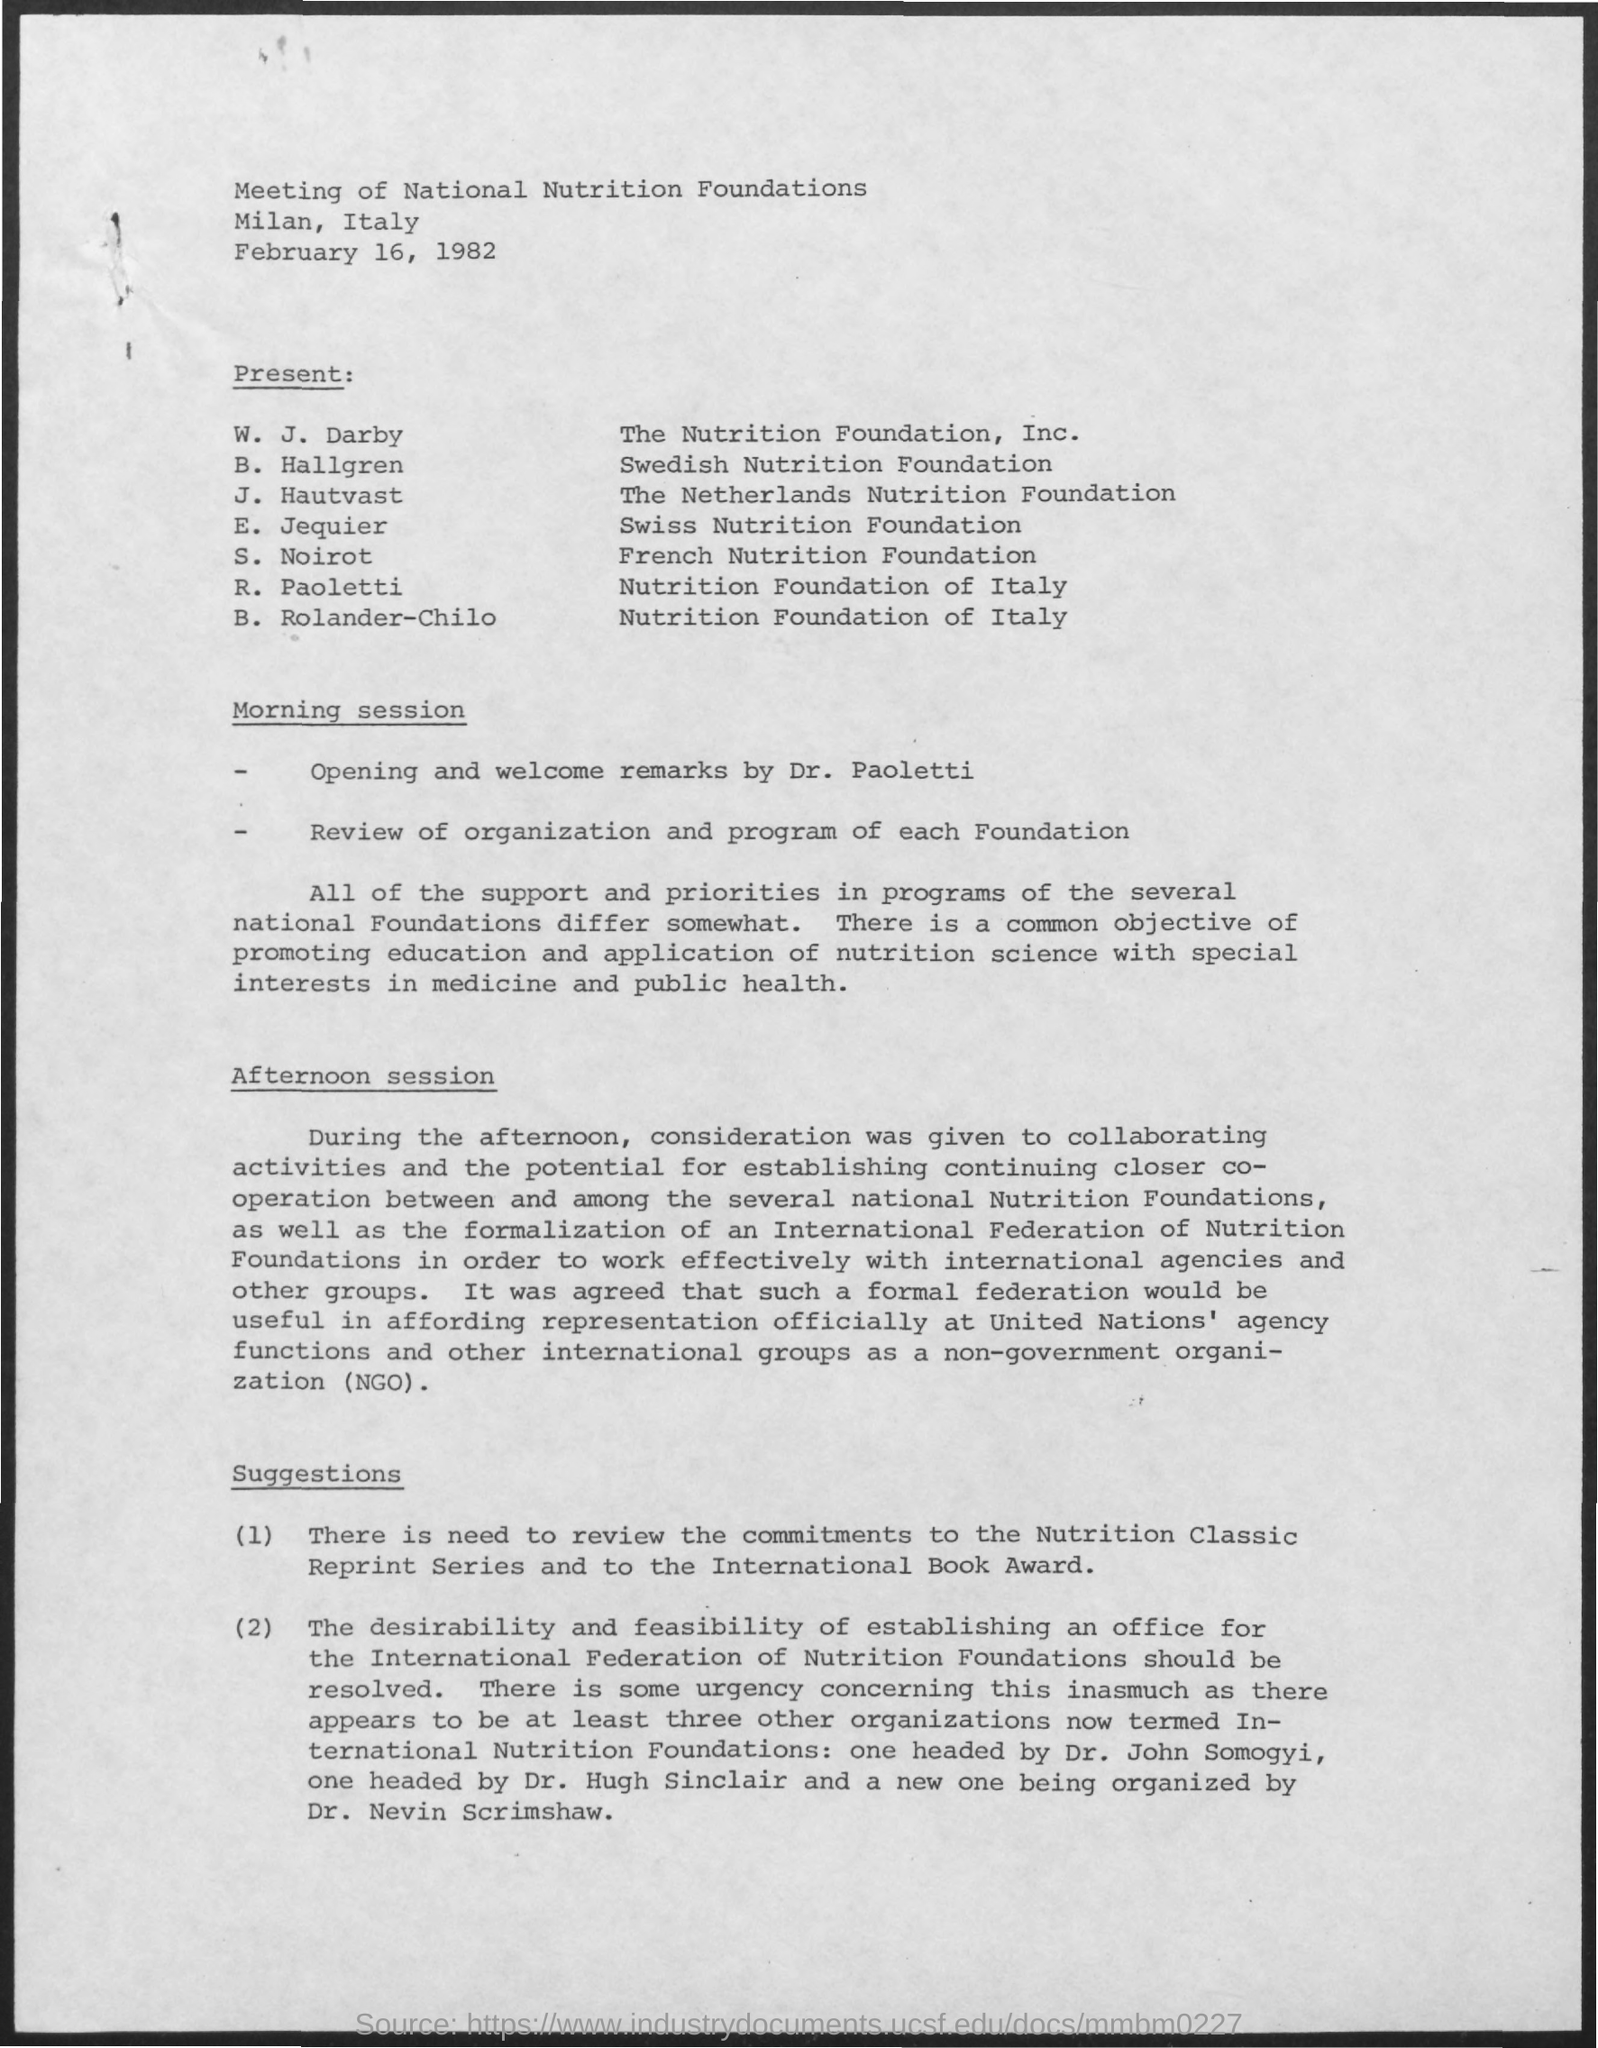List a handful of essential elements in this visual. J. Hautvast is a member of the Netherlands Nutrition Foundation. The meeting was conducted in Milan, Italy. B. Hallgren is affiliated with the Swedish Nutrition Foundation. On February 16, 1982, the meeting was scheduled. S. Noirot is affiliated with the French Nutrition Foundation. 